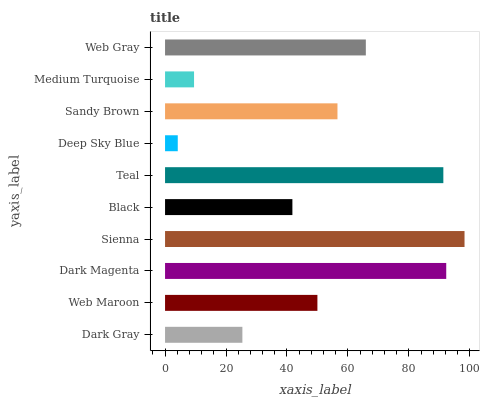Is Deep Sky Blue the minimum?
Answer yes or no. Yes. Is Sienna the maximum?
Answer yes or no. Yes. Is Web Maroon the minimum?
Answer yes or no. No. Is Web Maroon the maximum?
Answer yes or no. No. Is Web Maroon greater than Dark Gray?
Answer yes or no. Yes. Is Dark Gray less than Web Maroon?
Answer yes or no. Yes. Is Dark Gray greater than Web Maroon?
Answer yes or no. No. Is Web Maroon less than Dark Gray?
Answer yes or no. No. Is Sandy Brown the high median?
Answer yes or no. Yes. Is Web Maroon the low median?
Answer yes or no. Yes. Is Web Gray the high median?
Answer yes or no. No. Is Sienna the low median?
Answer yes or no. No. 